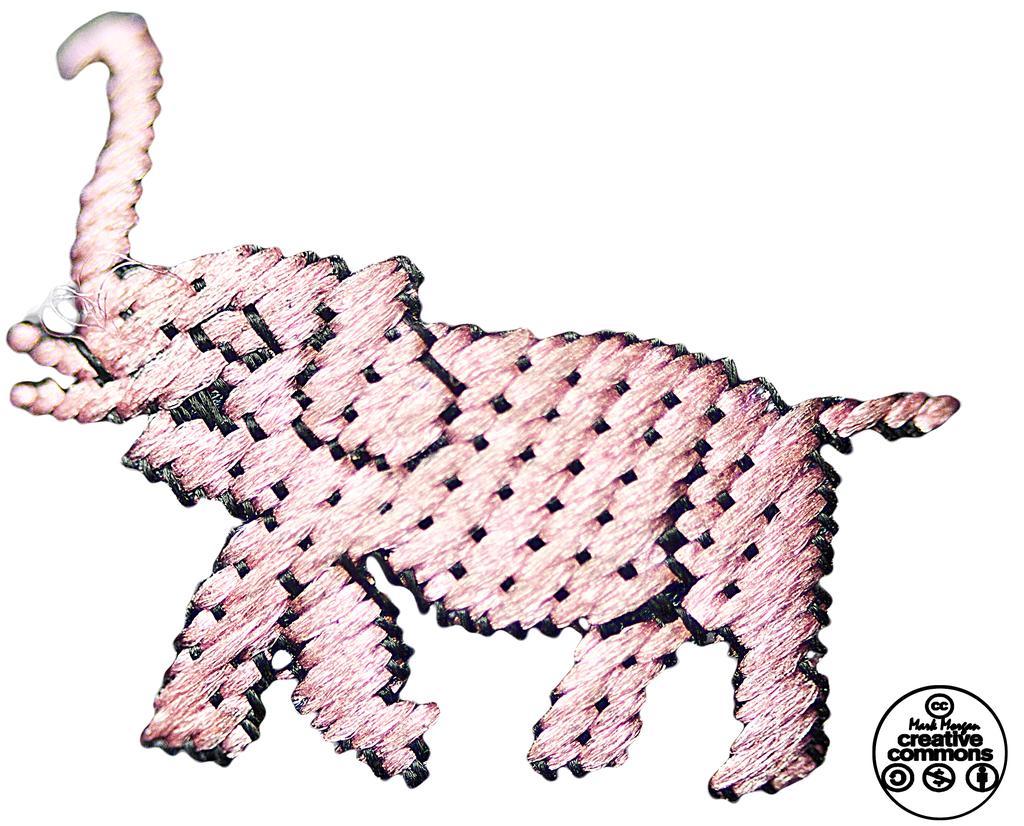Could you give a brief overview of what you see in this image? In the center of the image we can see the painting of an elephant. In the bottom right corner we can see the text and logos. 